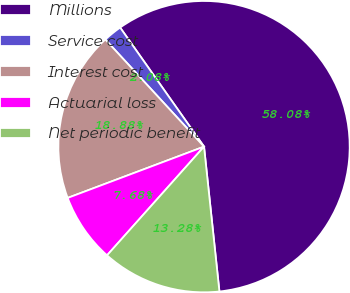Convert chart to OTSL. <chart><loc_0><loc_0><loc_500><loc_500><pie_chart><fcel>Millions<fcel>Service cost<fcel>Interest cost<fcel>Actuarial loss<fcel>Net periodic benefit<nl><fcel>58.09%<fcel>2.08%<fcel>18.88%<fcel>7.68%<fcel>13.28%<nl></chart> 